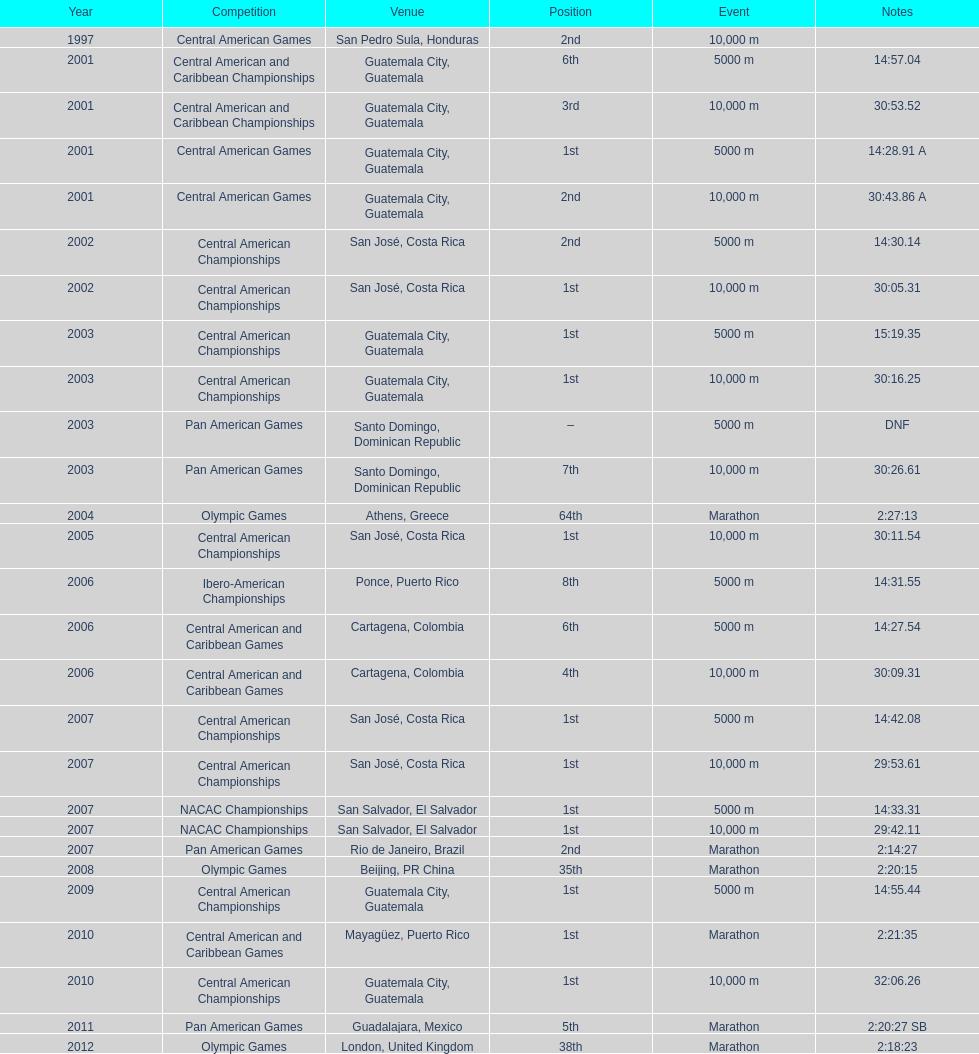In the final contest, when was a "2nd" place position accomplished? Pan American Games. 